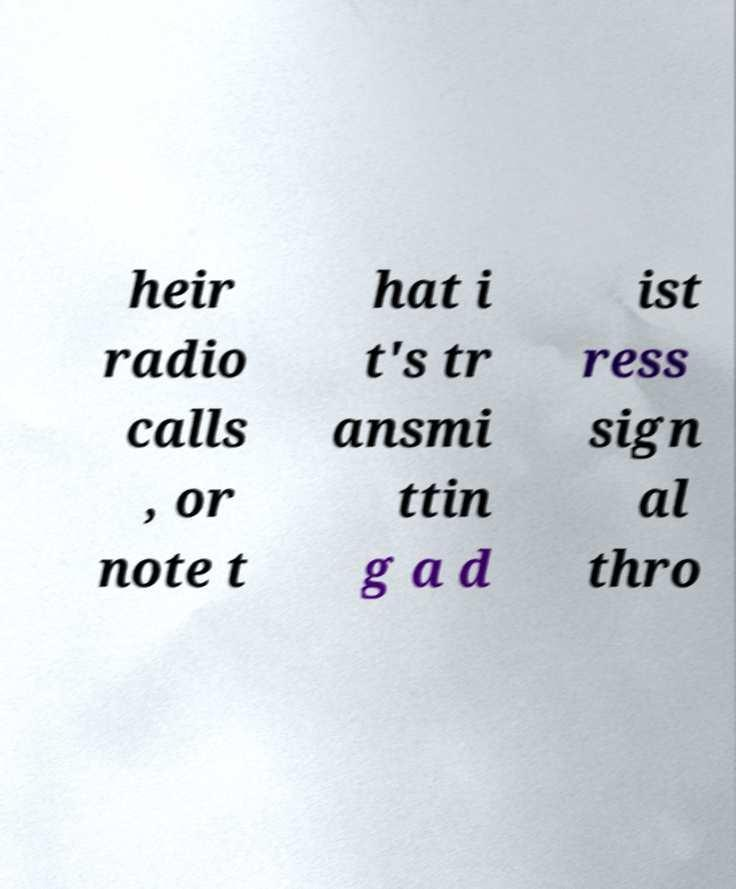Could you assist in decoding the text presented in this image and type it out clearly? heir radio calls , or note t hat i t's tr ansmi ttin g a d ist ress sign al thro 